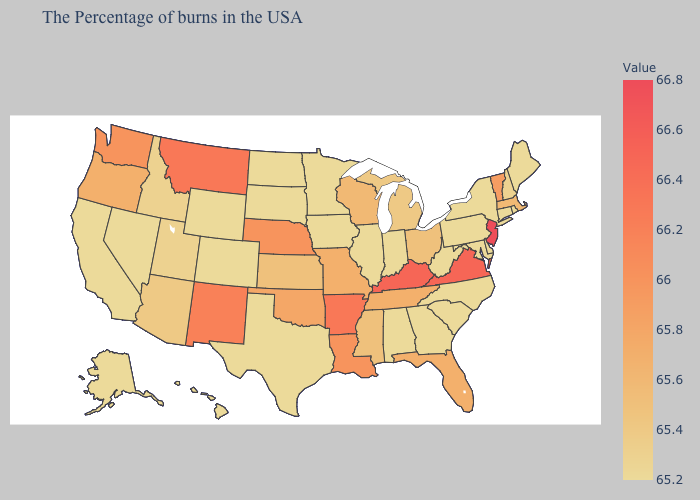Among the states that border Kentucky , does Illinois have the highest value?
Be succinct. No. Among the states that border New Mexico , which have the lowest value?
Give a very brief answer. Texas, Colorado. Which states have the lowest value in the West?
Answer briefly. Wyoming, Colorado, Nevada, California, Alaska, Hawaii. Which states have the lowest value in the USA?
Concise answer only. Maine, Rhode Island, Connecticut, New York, Delaware, Maryland, Pennsylvania, North Carolina, South Carolina, West Virginia, Georgia, Indiana, Alabama, Illinois, Minnesota, Iowa, Texas, South Dakota, North Dakota, Wyoming, Colorado, Nevada, California, Alaska, Hawaii. Does North Dakota have the highest value in the USA?
Quick response, please. No. Does the map have missing data?
Short answer required. No. 